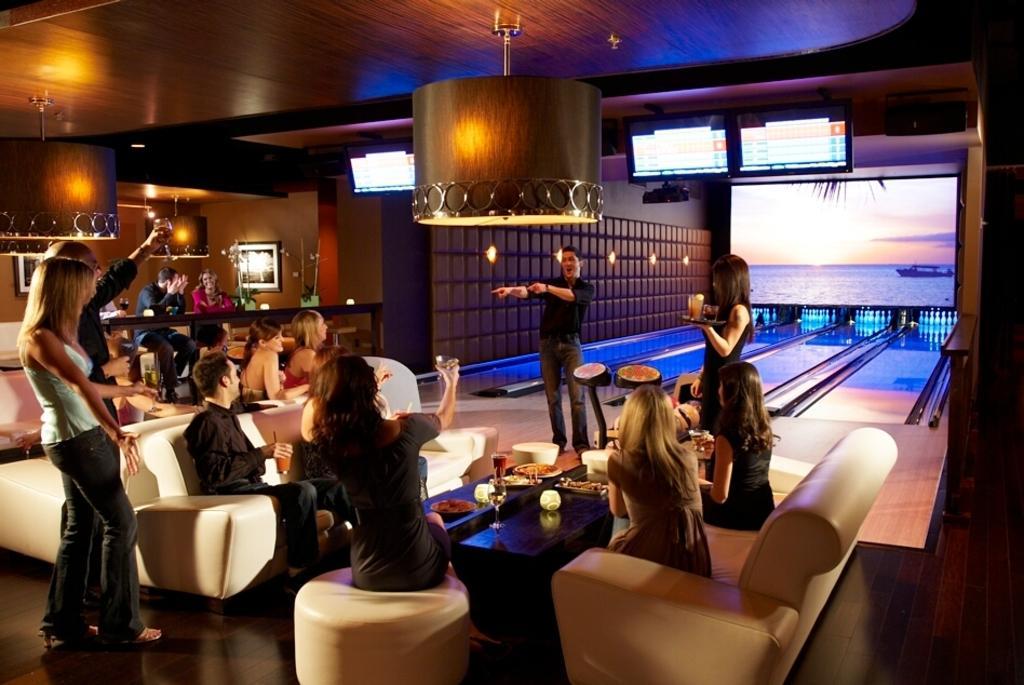Please provide a concise description of this image. Here there is a light on the top and there are so many sofas in the middle of the room. And there a table on left side and there are two persons sitting over there. One man and a woman. woman is smiling there. and here on the left side there is a person standing, two persons standing and in the middle of the room there is a table which has glasses and a vessel and near that there are sofas, on the sofas there are 5 people sitting and there is a person who is standing near them who is holding two glasses and the another person is standing and he is talking something , he is pointing someone and there are two screens on the top. 